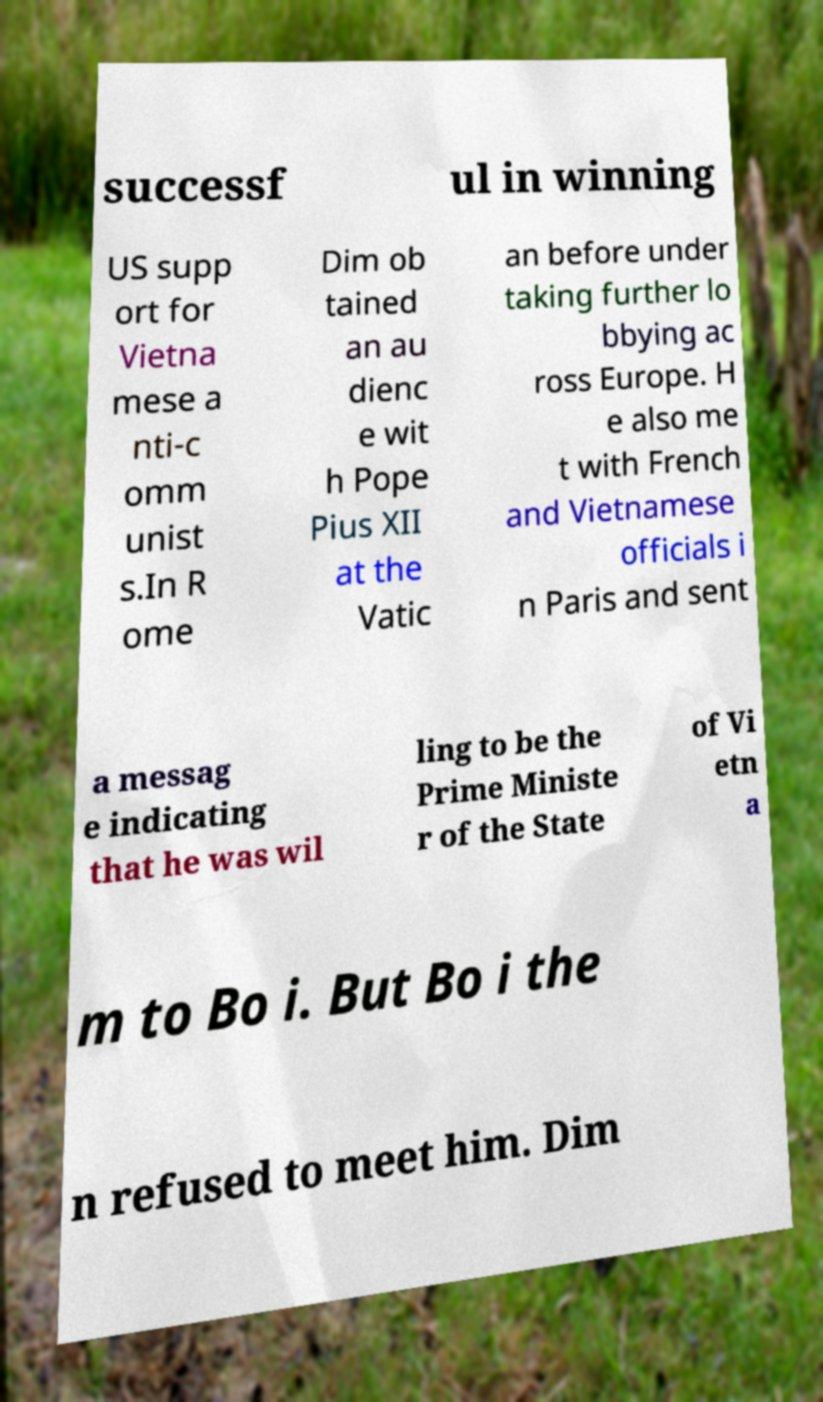Could you assist in decoding the text presented in this image and type it out clearly? successf ul in winning US supp ort for Vietna mese a nti-c omm unist s.In R ome Dim ob tained an au dienc e wit h Pope Pius XII at the Vatic an before under taking further lo bbying ac ross Europe. H e also me t with French and Vietnamese officials i n Paris and sent a messag e indicating that he was wil ling to be the Prime Ministe r of the State of Vi etn a m to Bo i. But Bo i the n refused to meet him. Dim 